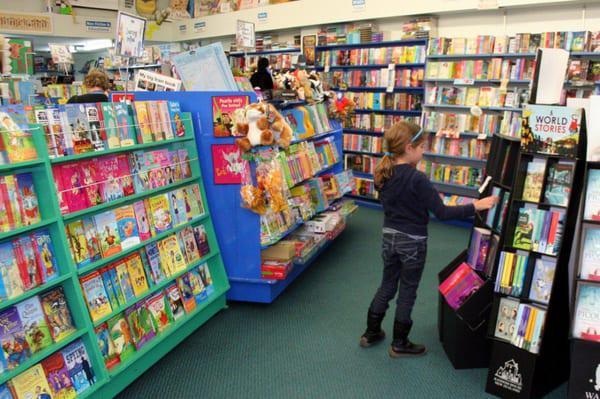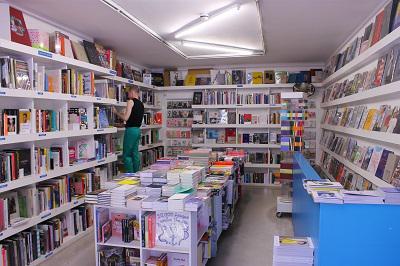The first image is the image on the left, the second image is the image on the right. Examine the images to the left and right. Is the description "There is seating visible in at least one of the images." accurate? Answer yes or no. No. The first image is the image on the left, the second image is the image on the right. For the images displayed, is the sentence "Atleast one building has a wooden floor." factually correct? Answer yes or no. No. 